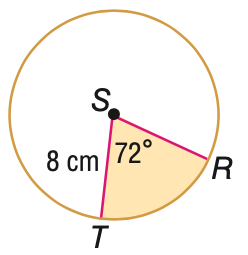Answer the mathemtical geometry problem and directly provide the correct option letter.
Question: Find the area of the shaded sector. Round to the nearest tenth, if necessary.
Choices: A: 40.2 B: 80.4 C: 160.8 D: 201.1 A 